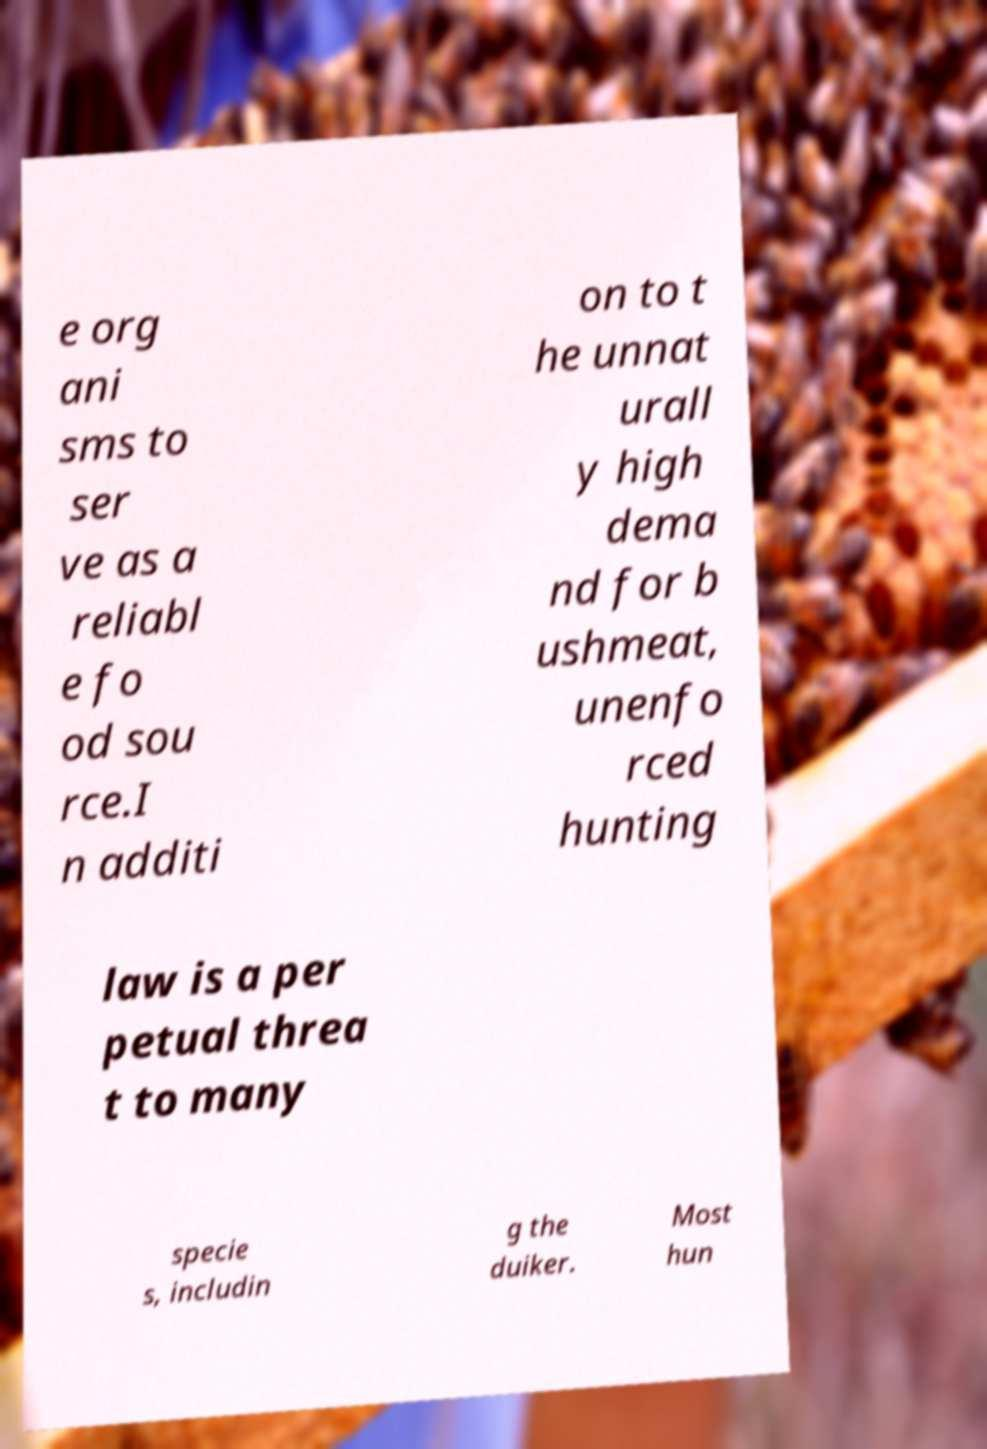Can you accurately transcribe the text from the provided image for me? e org ani sms to ser ve as a reliabl e fo od sou rce.I n additi on to t he unnat urall y high dema nd for b ushmeat, unenfo rced hunting law is a per petual threa t to many specie s, includin g the duiker. Most hun 